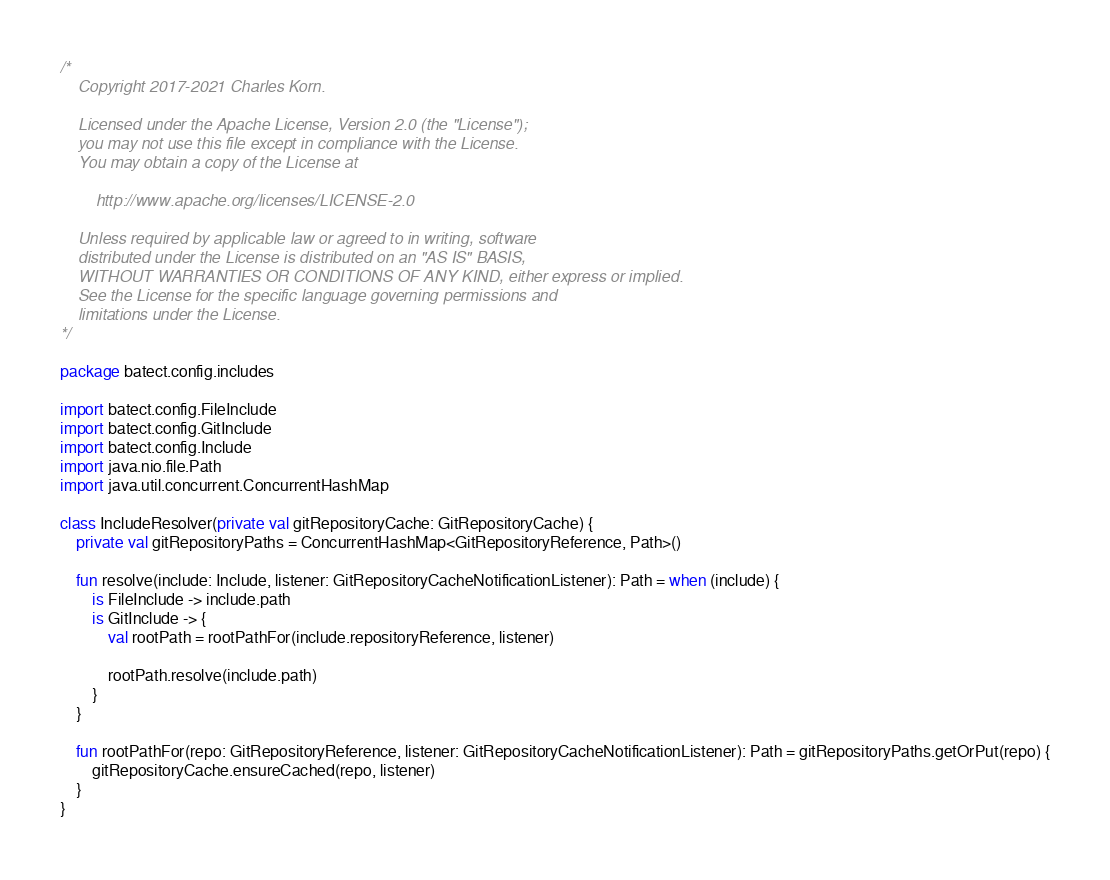Convert code to text. <code><loc_0><loc_0><loc_500><loc_500><_Kotlin_>/*
    Copyright 2017-2021 Charles Korn.

    Licensed under the Apache License, Version 2.0 (the "License");
    you may not use this file except in compliance with the License.
    You may obtain a copy of the License at

        http://www.apache.org/licenses/LICENSE-2.0

    Unless required by applicable law or agreed to in writing, software
    distributed under the License is distributed on an "AS IS" BASIS,
    WITHOUT WARRANTIES OR CONDITIONS OF ANY KIND, either express or implied.
    See the License for the specific language governing permissions and
    limitations under the License.
*/

package batect.config.includes

import batect.config.FileInclude
import batect.config.GitInclude
import batect.config.Include
import java.nio.file.Path
import java.util.concurrent.ConcurrentHashMap

class IncludeResolver(private val gitRepositoryCache: GitRepositoryCache) {
    private val gitRepositoryPaths = ConcurrentHashMap<GitRepositoryReference, Path>()

    fun resolve(include: Include, listener: GitRepositoryCacheNotificationListener): Path = when (include) {
        is FileInclude -> include.path
        is GitInclude -> {
            val rootPath = rootPathFor(include.repositoryReference, listener)

            rootPath.resolve(include.path)
        }
    }

    fun rootPathFor(repo: GitRepositoryReference, listener: GitRepositoryCacheNotificationListener): Path = gitRepositoryPaths.getOrPut(repo) {
        gitRepositoryCache.ensureCached(repo, listener)
    }
}
</code> 